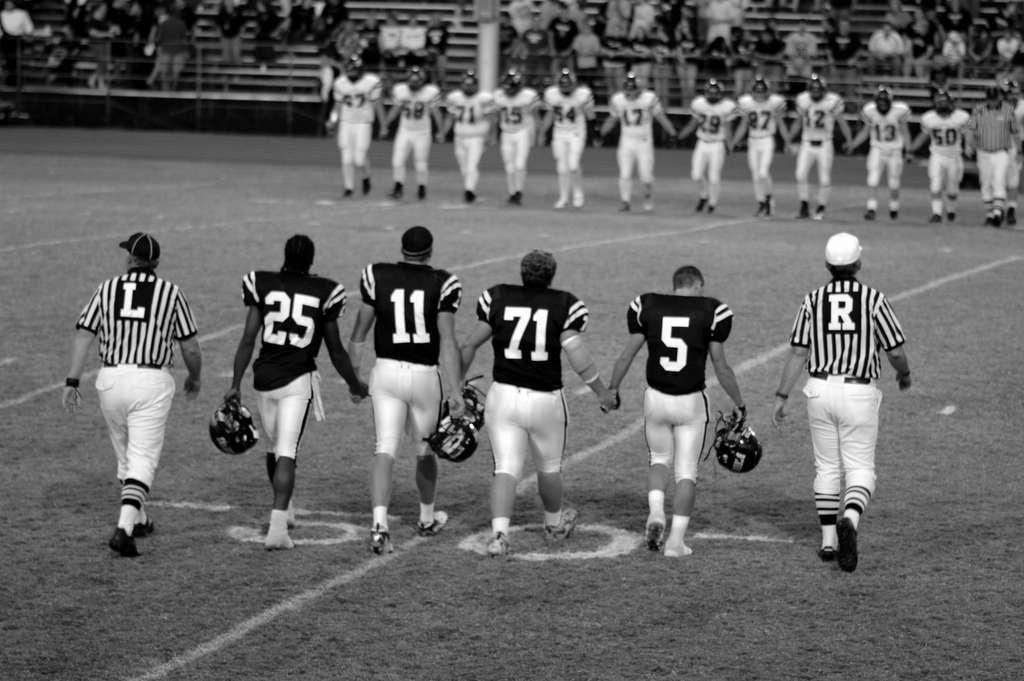<image>
Render a clear and concise summary of the photo. Football players hold hands while wearing jerseys with numbers like 25, 11, 71, and 5. 